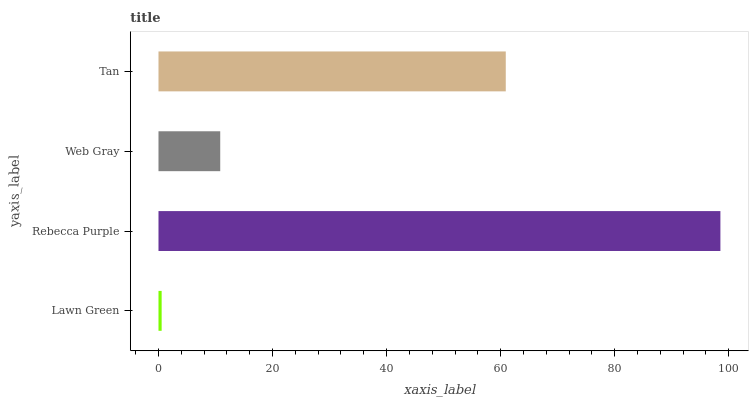Is Lawn Green the minimum?
Answer yes or no. Yes. Is Rebecca Purple the maximum?
Answer yes or no. Yes. Is Web Gray the minimum?
Answer yes or no. No. Is Web Gray the maximum?
Answer yes or no. No. Is Rebecca Purple greater than Web Gray?
Answer yes or no. Yes. Is Web Gray less than Rebecca Purple?
Answer yes or no. Yes. Is Web Gray greater than Rebecca Purple?
Answer yes or no. No. Is Rebecca Purple less than Web Gray?
Answer yes or no. No. Is Tan the high median?
Answer yes or no. Yes. Is Web Gray the low median?
Answer yes or no. Yes. Is Web Gray the high median?
Answer yes or no. No. Is Lawn Green the low median?
Answer yes or no. No. 